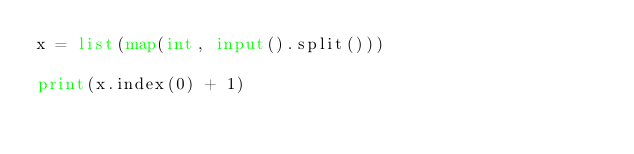Convert code to text. <code><loc_0><loc_0><loc_500><loc_500><_Python_>x = list(map(int, input().split()))

print(x.index(0) + 1)</code> 